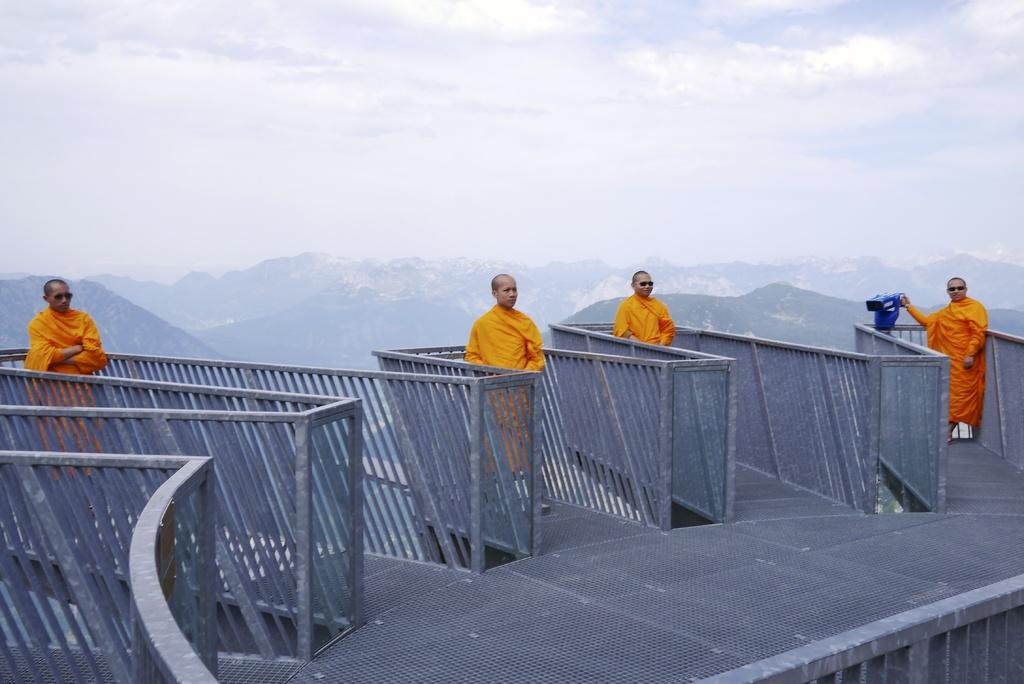What are the people standing on in the image? The people are standing on a mesh. What is the person holding in the image? One person is holding a blue object. What can be seen in the image that is used for cooking? There are grills visible in the image. What type of landscape can be seen in the background of the image? There are hills in the background of the image. What is visible in the sky in the image? The sky is visible in the background of the image, and clouds are present. What type of leg is visible in the image? There is no leg visible in the image; the people are standing on a mesh. What riddle can be solved by looking at the blue object in the image? There is no riddle associated with the blue object in the image. 